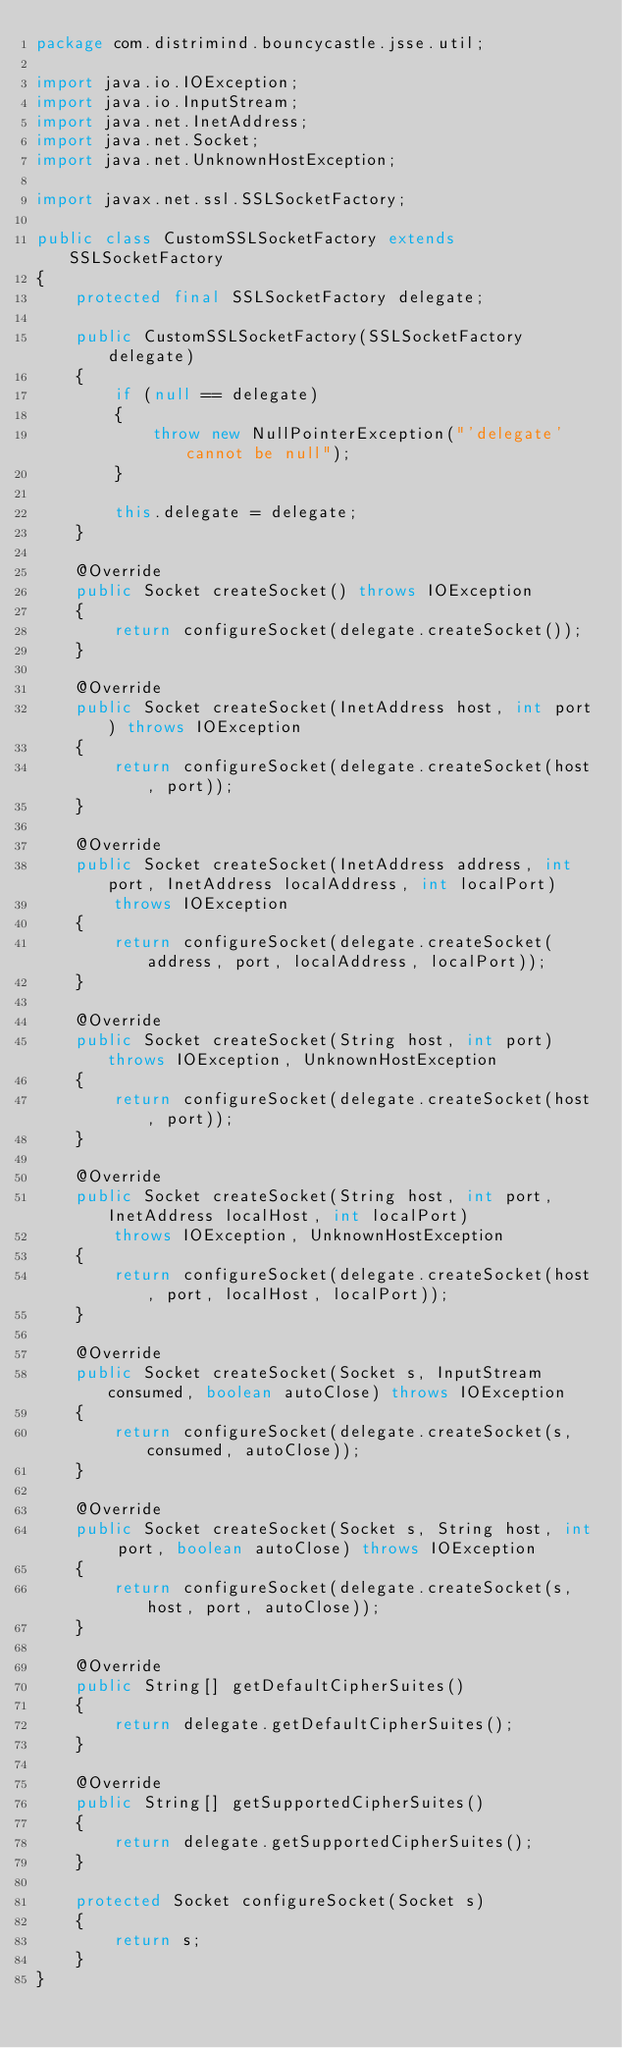Convert code to text. <code><loc_0><loc_0><loc_500><loc_500><_Java_>package com.distrimind.bouncycastle.jsse.util;

import java.io.IOException;
import java.io.InputStream;
import java.net.InetAddress;
import java.net.Socket;
import java.net.UnknownHostException;

import javax.net.ssl.SSLSocketFactory;

public class CustomSSLSocketFactory extends SSLSocketFactory
{
    protected final SSLSocketFactory delegate;

    public CustomSSLSocketFactory(SSLSocketFactory delegate)
    {
        if (null == delegate)
        {
            throw new NullPointerException("'delegate' cannot be null");
        }

        this.delegate = delegate;
    }

    @Override
    public Socket createSocket() throws IOException
    {
        return configureSocket(delegate.createSocket());
    }

    @Override
    public Socket createSocket(InetAddress host, int port) throws IOException
    {
        return configureSocket(delegate.createSocket(host, port));
    }

    @Override
    public Socket createSocket(InetAddress address, int port, InetAddress localAddress, int localPort)
        throws IOException
    {
        return configureSocket(delegate.createSocket(address, port, localAddress, localPort));
    }

    @Override
    public Socket createSocket(String host, int port) throws IOException, UnknownHostException
    {
        return configureSocket(delegate.createSocket(host, port));
    }

    @Override
    public Socket createSocket(String host, int port, InetAddress localHost, int localPort)
        throws IOException, UnknownHostException
    {
        return configureSocket(delegate.createSocket(host, port, localHost, localPort));
    }

    @Override
    public Socket createSocket(Socket s, InputStream consumed, boolean autoClose) throws IOException
    {
        return configureSocket(delegate.createSocket(s, consumed, autoClose));
    }

    @Override
    public Socket createSocket(Socket s, String host, int port, boolean autoClose) throws IOException
    {
        return configureSocket(delegate.createSocket(s, host, port, autoClose));
    }

    @Override
    public String[] getDefaultCipherSuites()
    {
        return delegate.getDefaultCipherSuites();
    }

    @Override
    public String[] getSupportedCipherSuites()
    {
        return delegate.getSupportedCipherSuites();
    }

    protected Socket configureSocket(Socket s)
    {
        return s;
    }
}
</code> 